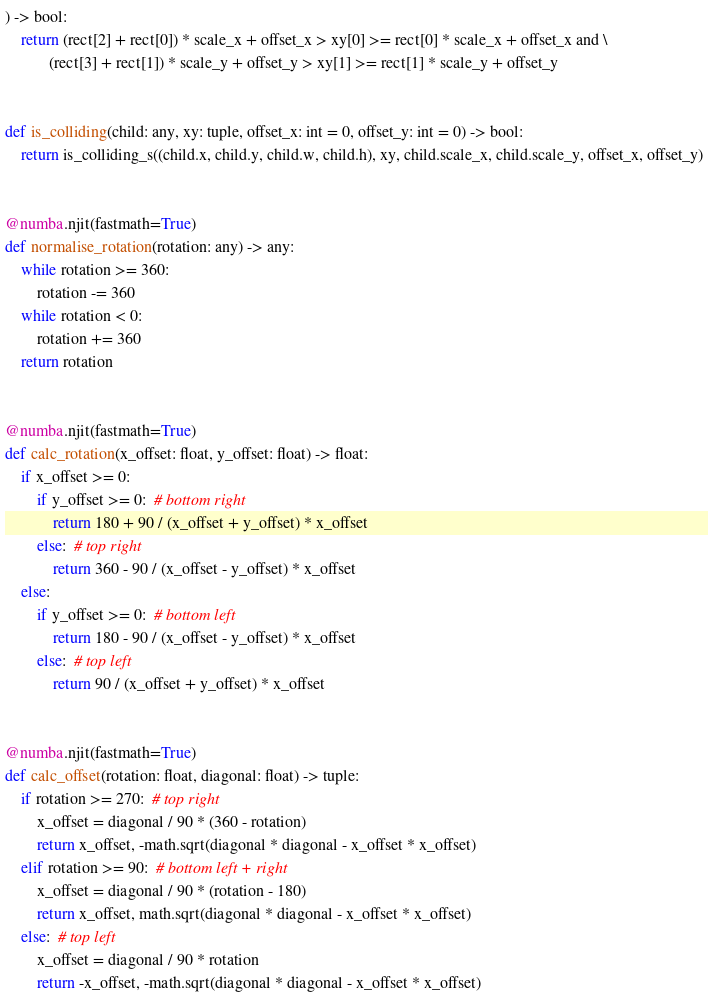Convert code to text. <code><loc_0><loc_0><loc_500><loc_500><_Python_>) -> bool:
    return (rect[2] + rect[0]) * scale_x + offset_x > xy[0] >= rect[0] * scale_x + offset_x and \
           (rect[3] + rect[1]) * scale_y + offset_y > xy[1] >= rect[1] * scale_y + offset_y


def is_colliding(child: any, xy: tuple, offset_x: int = 0, offset_y: int = 0) -> bool:
    return is_colliding_s((child.x, child.y, child.w, child.h), xy, child.scale_x, child.scale_y, offset_x, offset_y)


@numba.njit(fastmath=True)
def normalise_rotation(rotation: any) -> any:
    while rotation >= 360:
        rotation -= 360
    while rotation < 0:
        rotation += 360
    return rotation


@numba.njit(fastmath=True)
def calc_rotation(x_offset: float, y_offset: float) -> float:
    if x_offset >= 0:
        if y_offset >= 0:  # bottom right
            return 180 + 90 / (x_offset + y_offset) * x_offset
        else:  # top right
            return 360 - 90 / (x_offset - y_offset) * x_offset
    else:
        if y_offset >= 0:  # bottom left
            return 180 - 90 / (x_offset - y_offset) * x_offset
        else:  # top left
            return 90 / (x_offset + y_offset) * x_offset


@numba.njit(fastmath=True)
def calc_offset(rotation: float, diagonal: float) -> tuple:
    if rotation >= 270:  # top right
        x_offset = diagonal / 90 * (360 - rotation)
        return x_offset, -math.sqrt(diagonal * diagonal - x_offset * x_offset)
    elif rotation >= 90:  # bottom left + right
        x_offset = diagonal / 90 * (rotation - 180)
        return x_offset, math.sqrt(diagonal * diagonal - x_offset * x_offset)
    else:  # top left
        x_offset = diagonal / 90 * rotation
        return -x_offset, -math.sqrt(diagonal * diagonal - x_offset * x_offset)
</code> 